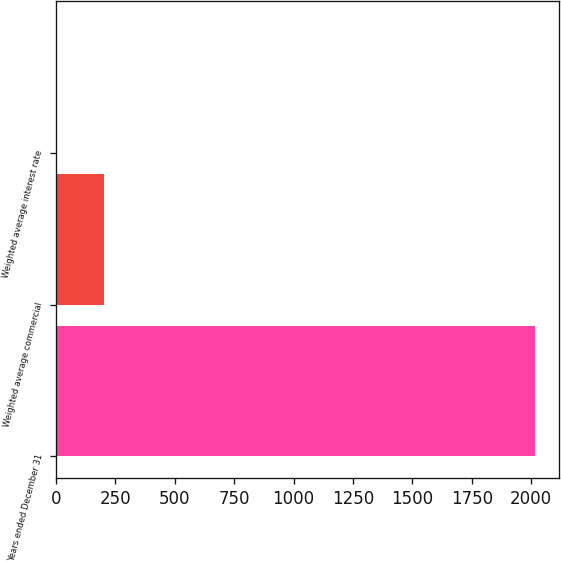Convert chart. <chart><loc_0><loc_0><loc_500><loc_500><bar_chart><fcel>Years ended December 31<fcel>Weighted average commercial<fcel>Weighted average interest rate<nl><fcel>2017<fcel>201.86<fcel>0.18<nl></chart> 